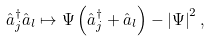<formula> <loc_0><loc_0><loc_500><loc_500>\hat { a } _ { j } ^ { \dagger } \hat { a } _ { l } \mapsto \Psi \left ( \hat { a } _ { j } ^ { \dagger } + \hat { a } _ { l } \right ) - \left | \Psi \right | ^ { 2 } ,</formula> 